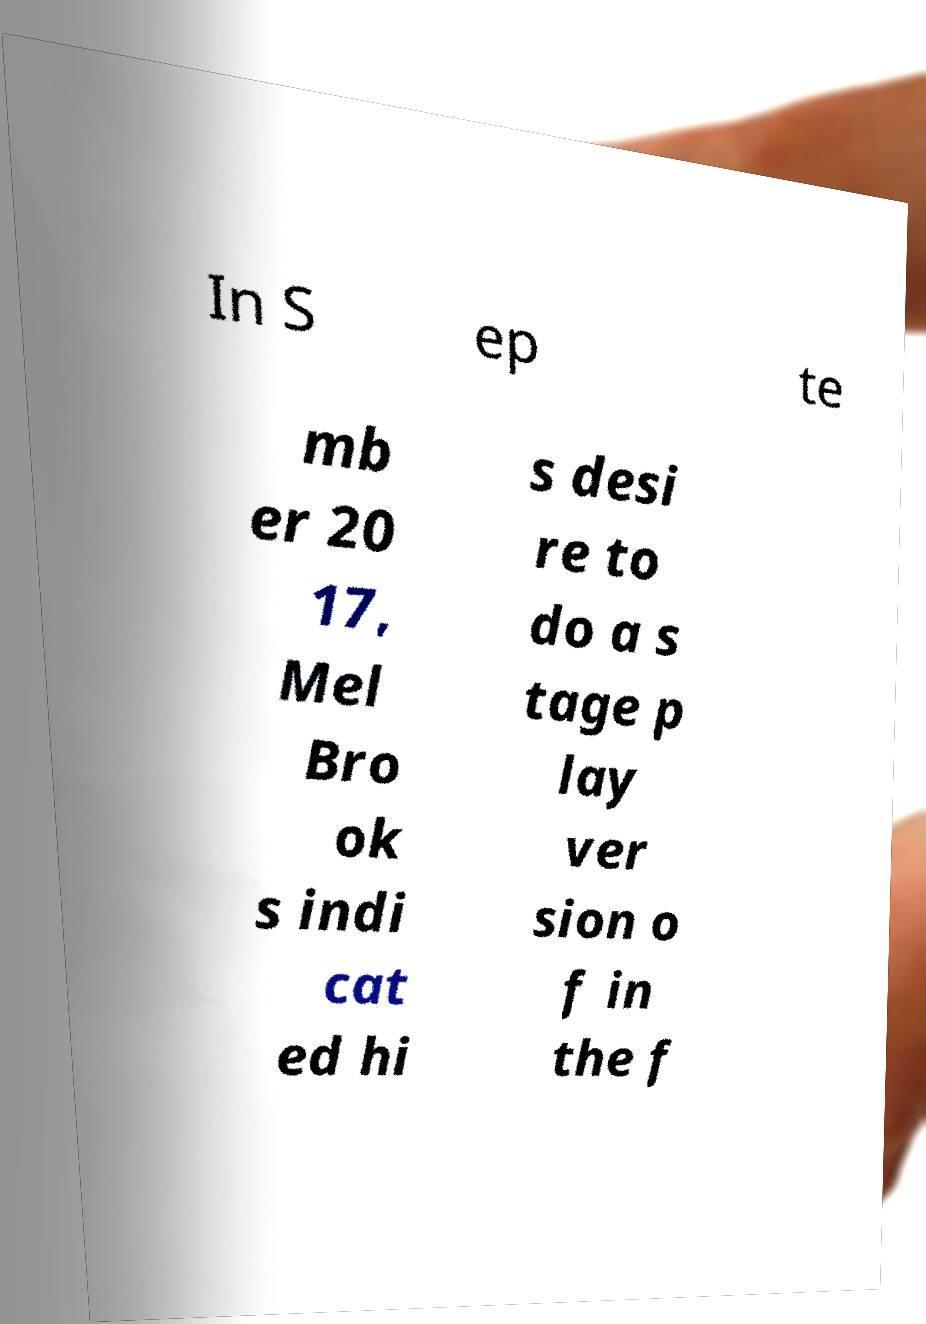Can you read and provide the text displayed in the image?This photo seems to have some interesting text. Can you extract and type it out for me? In S ep te mb er 20 17, Mel Bro ok s indi cat ed hi s desi re to do a s tage p lay ver sion o f in the f 